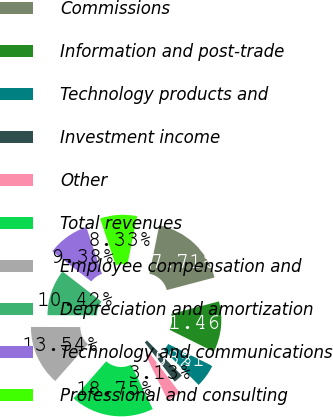<chart> <loc_0><loc_0><loc_500><loc_500><pie_chart><fcel>Commissions<fcel>Information and post-trade<fcel>Technology products and<fcel>Investment income<fcel>Other<fcel>Total revenues<fcel>Employee compensation and<fcel>Depreciation and amortization<fcel>Technology and communications<fcel>Professional and consulting<nl><fcel>17.71%<fcel>11.46%<fcel>5.21%<fcel>2.08%<fcel>3.13%<fcel>18.75%<fcel>13.54%<fcel>10.42%<fcel>9.38%<fcel>8.33%<nl></chart> 